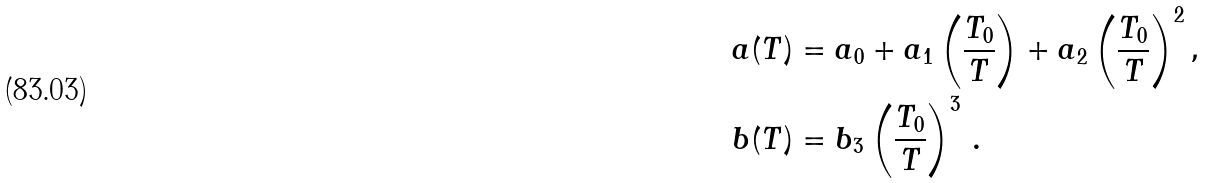<formula> <loc_0><loc_0><loc_500><loc_500>a ( T ) & = a _ { 0 } + a _ { 1 } \left ( \frac { T _ { 0 } } { T } \right ) + a _ { 2 } \left ( \frac { T _ { 0 } } { T } \right ) ^ { 2 } , \\ b ( T ) & = b _ { 3 } \left ( \frac { T _ { 0 } } { T } \right ) ^ { 3 } \, .</formula> 